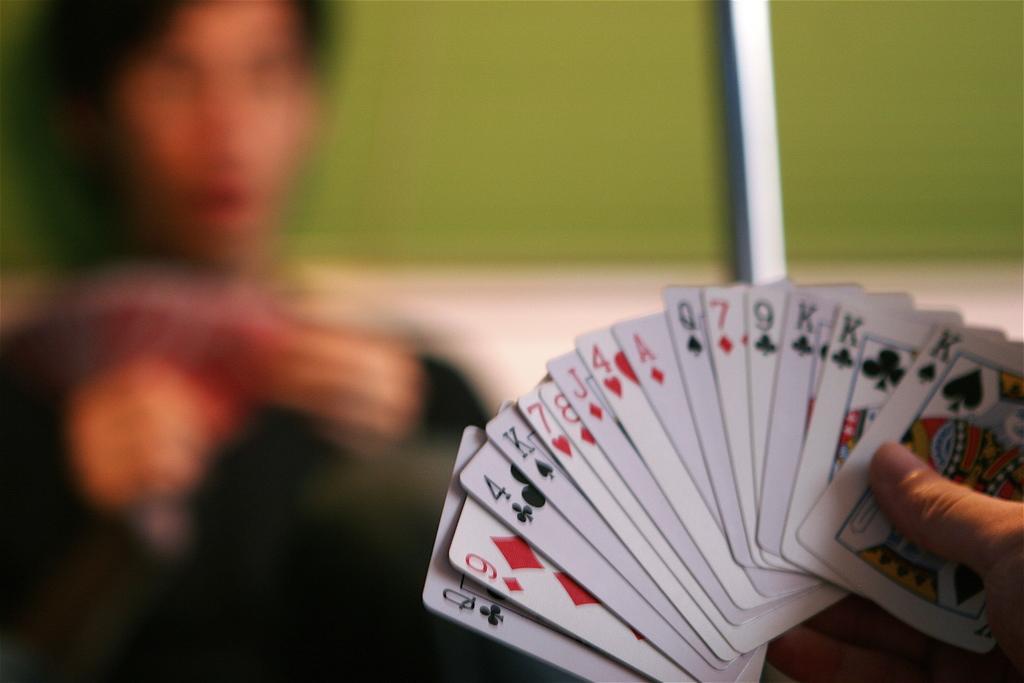How would you summarize this image in a sentence or two? In this image we can see hand of a person holding cards. There is a blur background and we can see a person. 